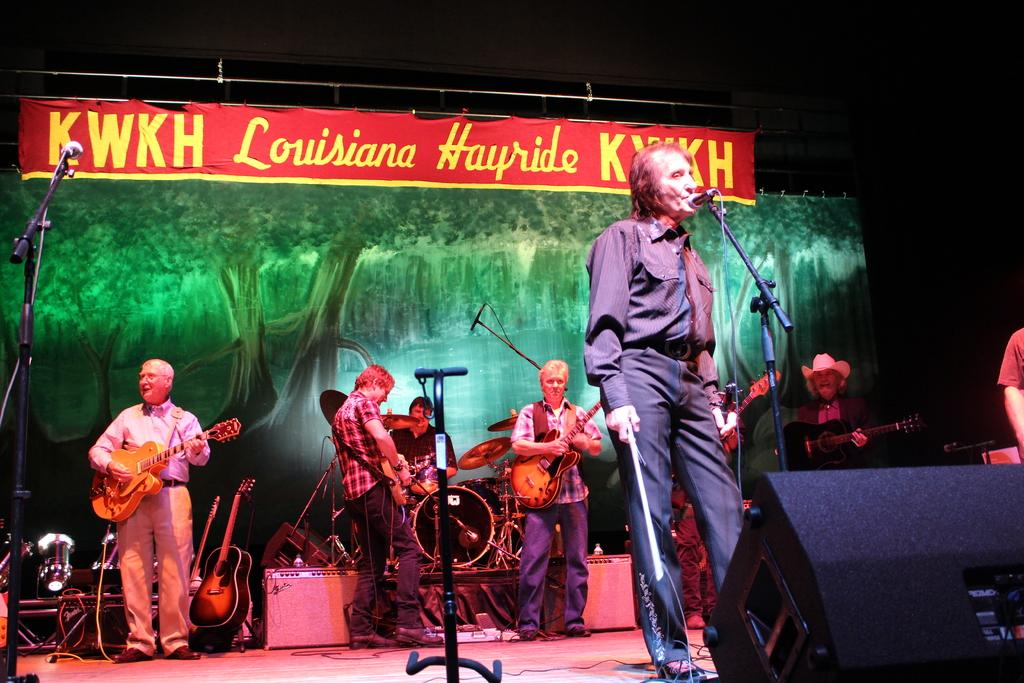Who or what is present in the image? There are people in the image. What are the people doing in the image? The people are standing in the image. What objects are the people holding in their hands? The people are holding guitars in their hands. What type of stove can be seen in the image? There is no stove present in the image. What thrilling activity are the people participating in while holding the guitars? The image does not depict any specific activity or thrill; it simply shows people standing and holding guitars. 